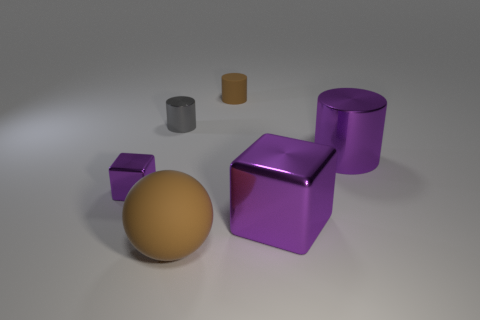Add 2 small red spheres. How many objects exist? 8 Subtract all metal cylinders. How many cylinders are left? 1 Subtract all blocks. How many objects are left? 4 Add 6 tiny brown rubber cylinders. How many tiny brown rubber cylinders exist? 7 Subtract 1 purple cylinders. How many objects are left? 5 Subtract all cyan cylinders. Subtract all yellow spheres. How many cylinders are left? 3 Subtract all red shiny things. Subtract all big metallic cubes. How many objects are left? 5 Add 6 large metallic things. How many large metallic things are left? 8 